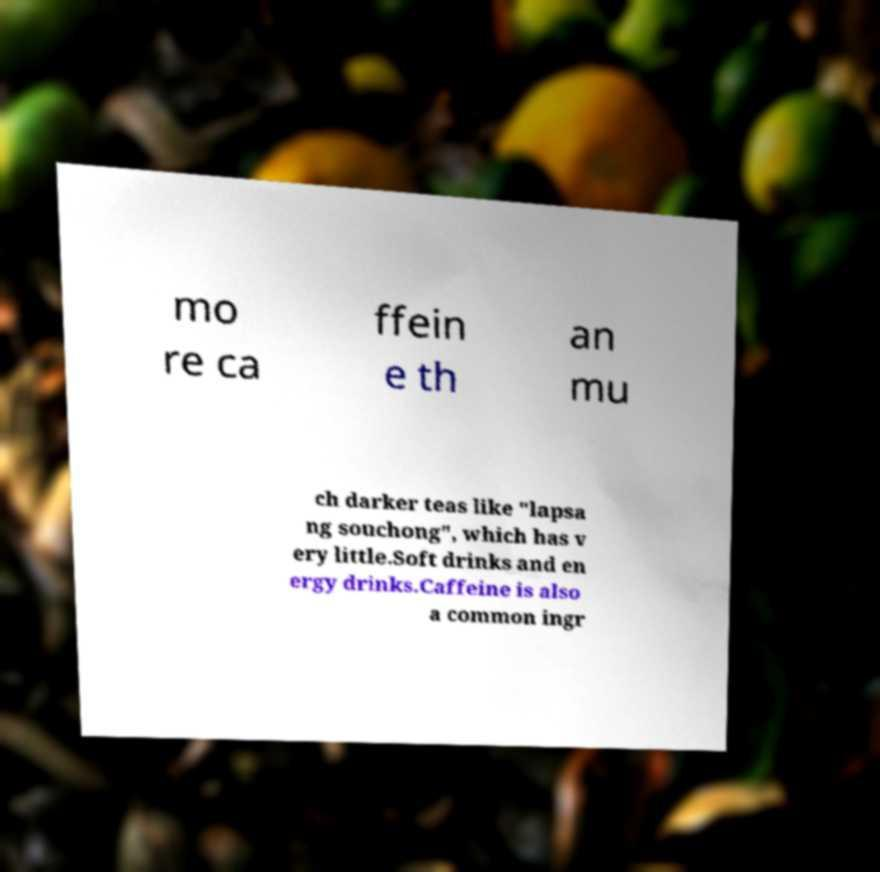There's text embedded in this image that I need extracted. Can you transcribe it verbatim? mo re ca ffein e th an mu ch darker teas like "lapsa ng souchong", which has v ery little.Soft drinks and en ergy drinks.Caffeine is also a common ingr 